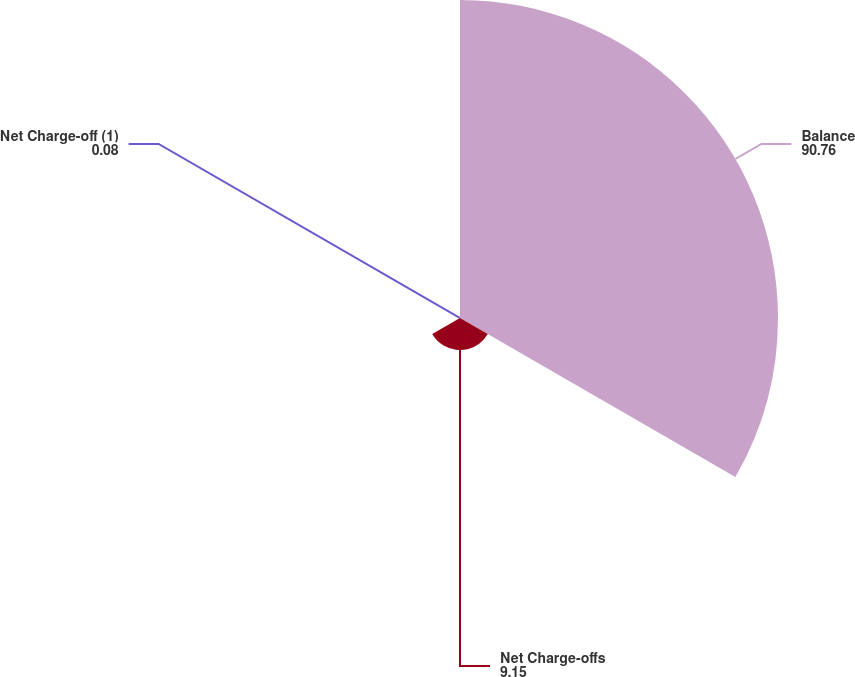Convert chart. <chart><loc_0><loc_0><loc_500><loc_500><pie_chart><fcel>Balance<fcel>Net Charge-offs<fcel>Net Charge-off (1)<nl><fcel>90.76%<fcel>9.15%<fcel>0.08%<nl></chart> 